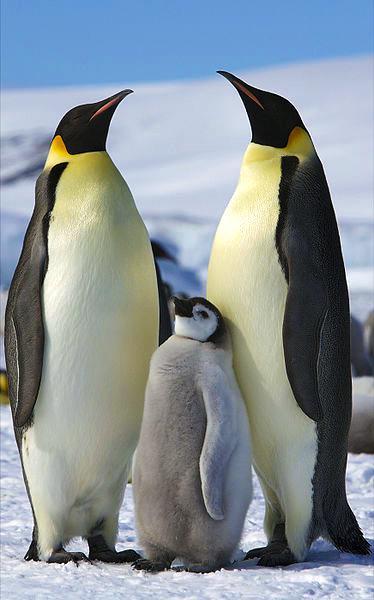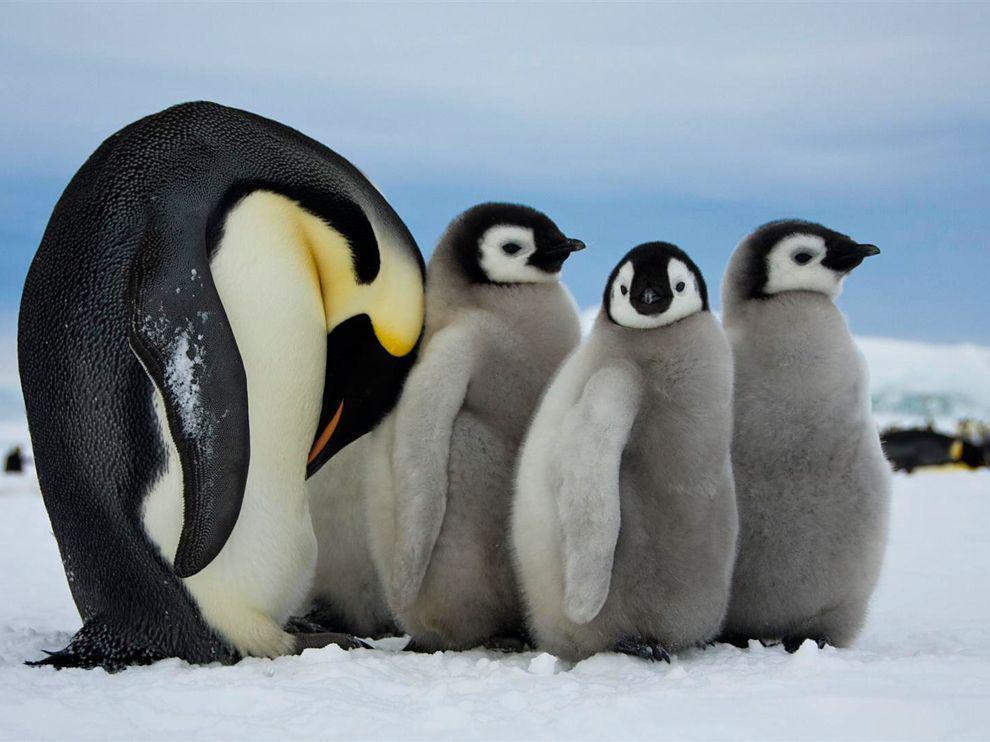The first image is the image on the left, the second image is the image on the right. For the images shown, is this caption "An image shows penguin parents with beaks pointed down toward their offspring." true? Answer yes or no. No. 